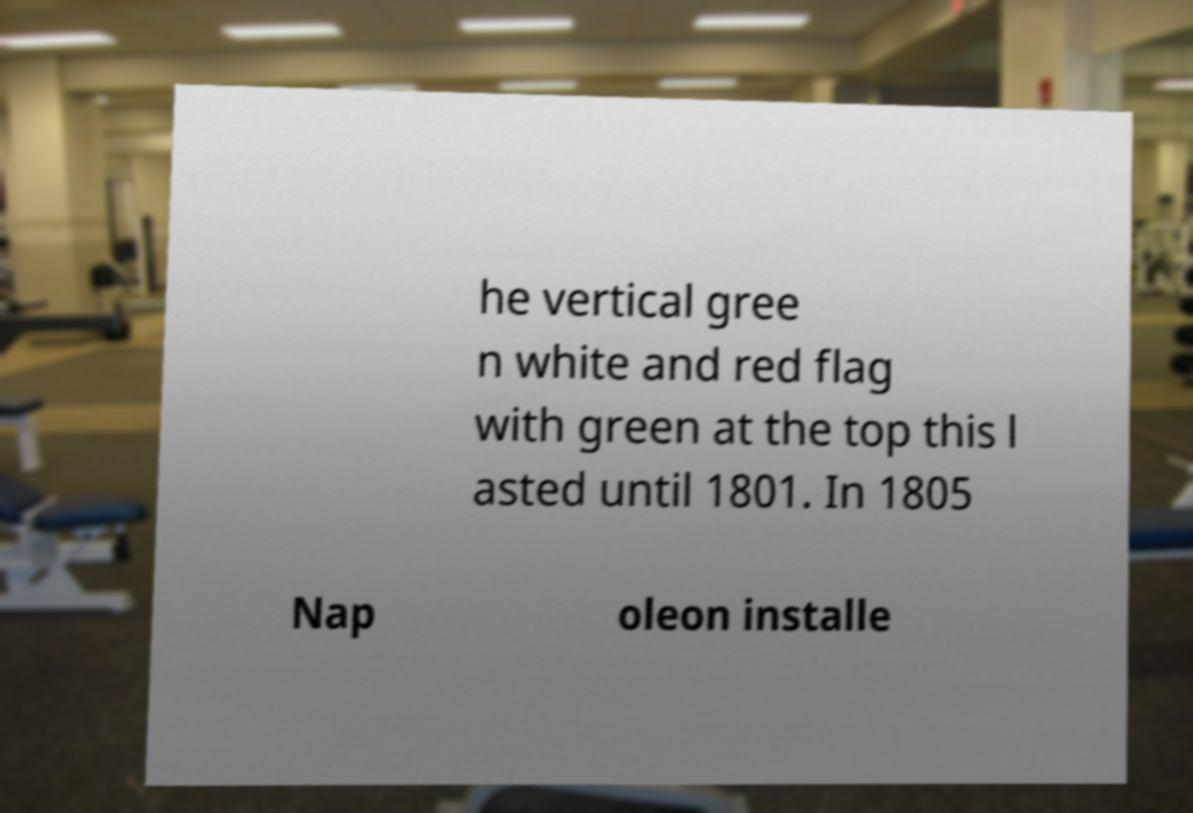Please read and relay the text visible in this image. What does it say? he vertical gree n white and red flag with green at the top this l asted until 1801. In 1805 Nap oleon installe 